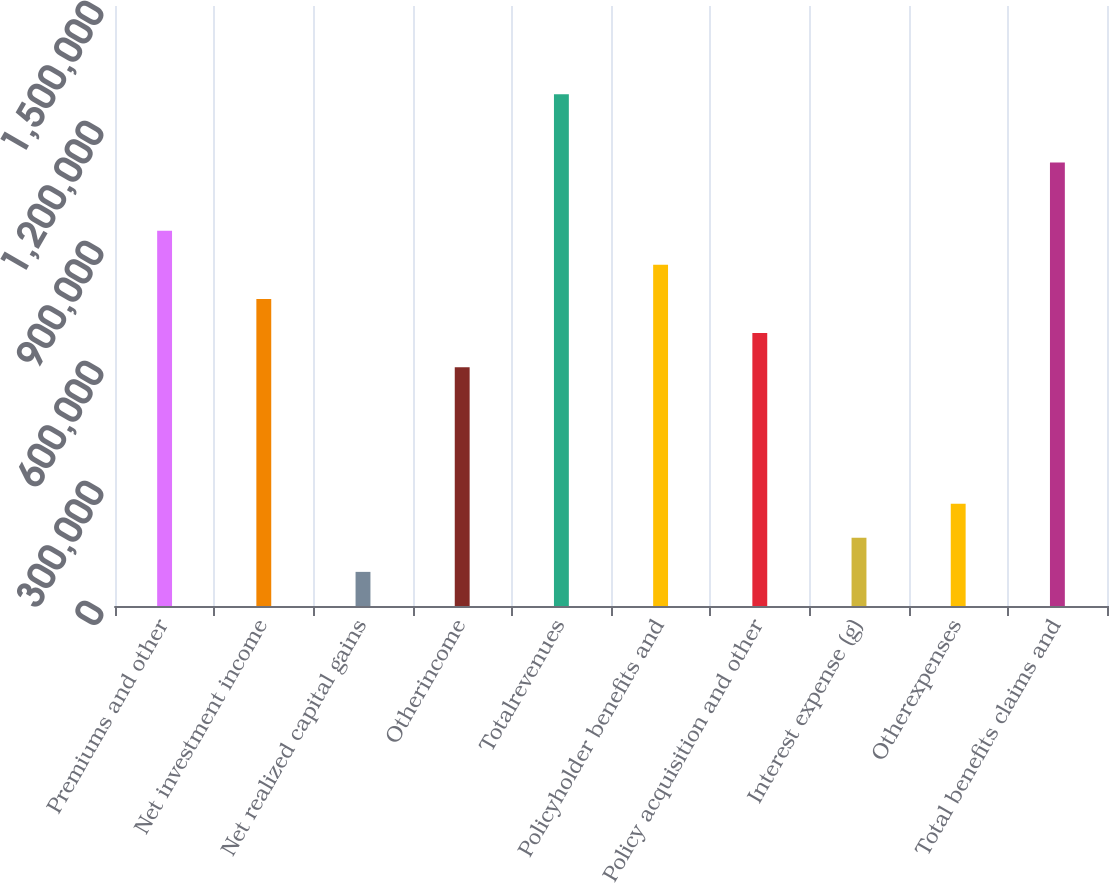Convert chart. <chart><loc_0><loc_0><loc_500><loc_500><bar_chart><fcel>Premiums and other<fcel>Net investment income<fcel>Net realized capital gains<fcel>Otherincome<fcel>Totalrevenues<fcel>Policyholder benefits and<fcel>Policy acquisition and other<fcel>Interest expense (g)<fcel>Otherexpenses<fcel>Total benefits claims and<nl><fcel>938353<fcel>767743<fcel>85305.4<fcel>597134<fcel>1.27957e+06<fcel>853048<fcel>682439<fcel>170610<fcel>255915<fcel>1.10896e+06<nl></chart> 